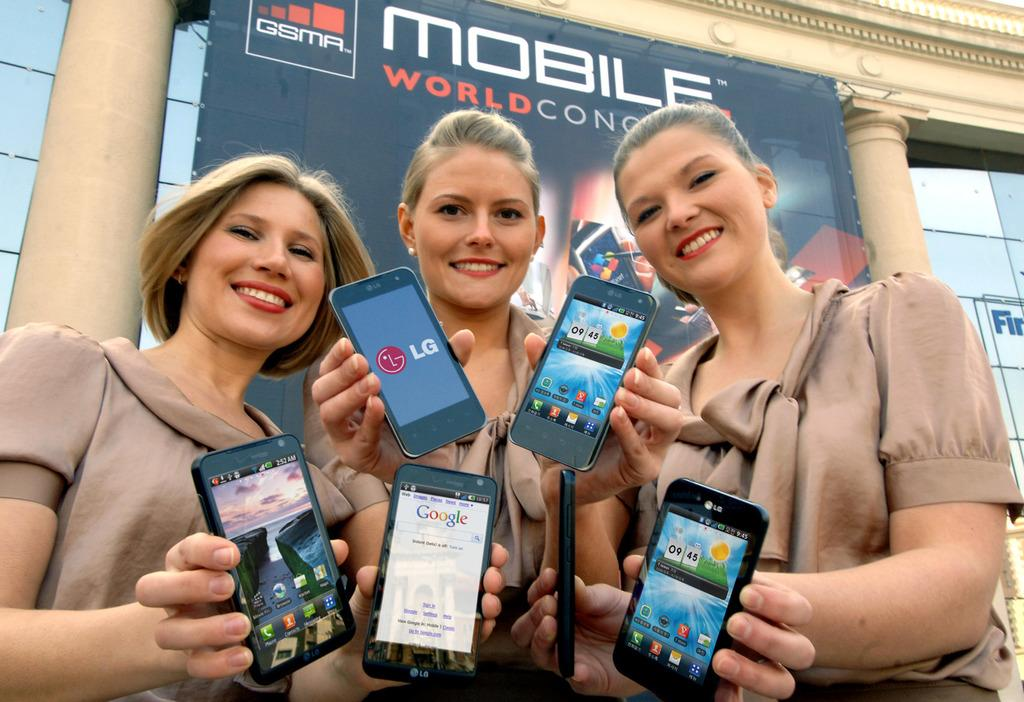<image>
Write a terse but informative summary of the picture. three women are holding LG phones in therr hands 